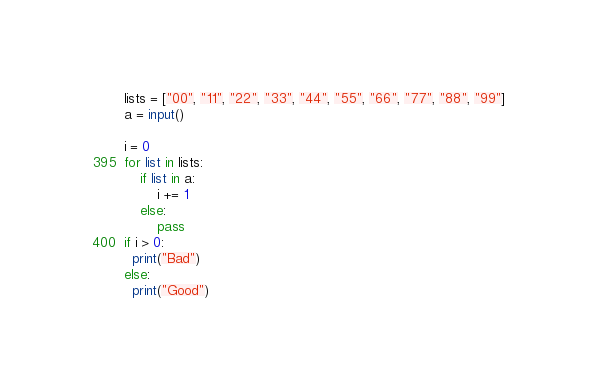Convert code to text. <code><loc_0><loc_0><loc_500><loc_500><_Python_>lists = ["00", "11", "22", "33", "44", "55", "66", "77", "88", "99"]
a = input()

i = 0
for list in lists:
    if list in a:
        i += 1
    else:
        pass
if i > 0:
  print("Bad")
else:
  print("Good")</code> 